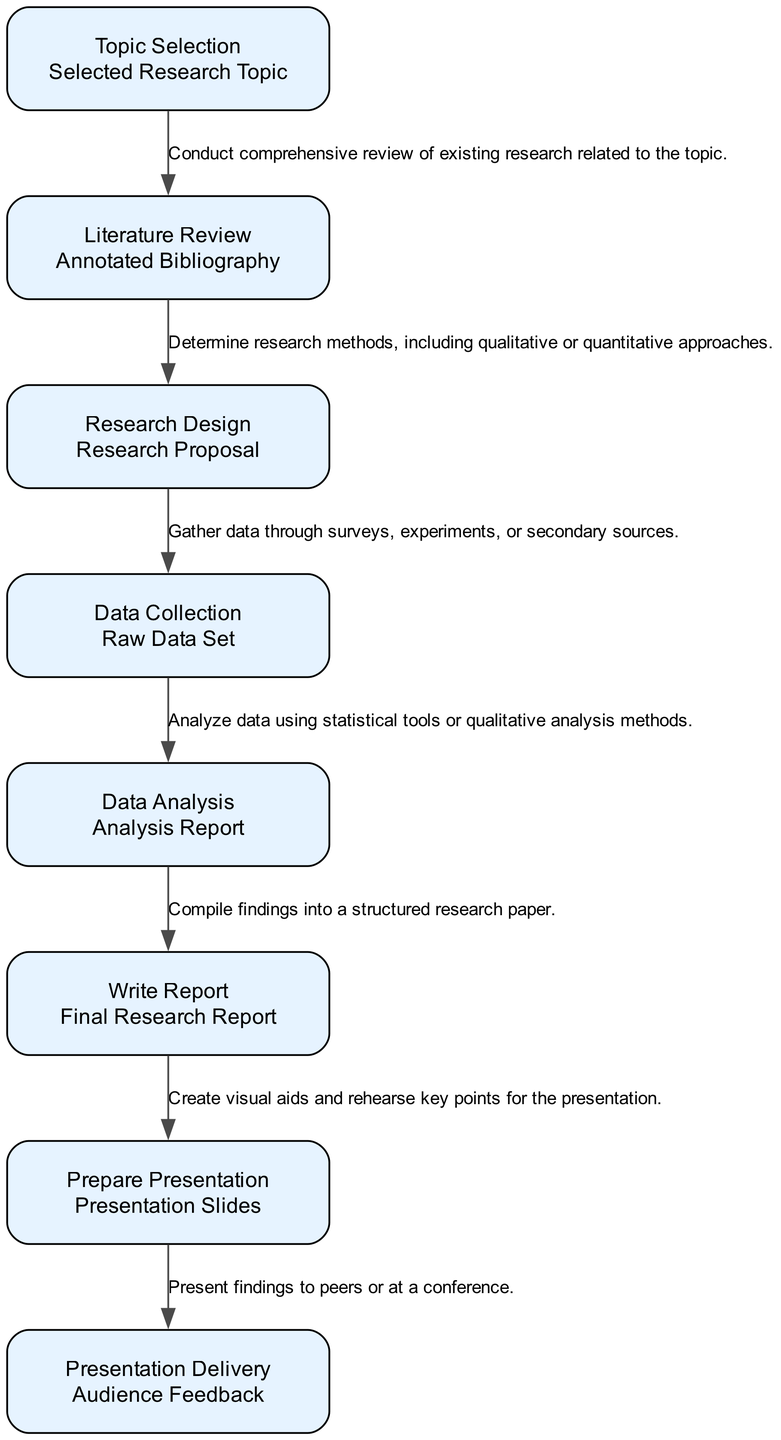What is the first step in the research project workflow? The workflow begins with "Topic Selection" as the first step. This is clearly indicated as the starting point in the diagram.
Answer: Topic Selection How many steps are in the research project workflow? By counting each distinct step listed in the diagram, there are eight steps in total.
Answer: 8 What is the output of the "Data Analysis" step? The output of the "Data Analysis" step is detailed in the diagram and is labeled as "Analysis Report."
Answer: Analysis Report What follows the "Research Design" step in the workflow? The workflow indicates that "Data Collection" follows "Research Design." This is shown by the arrow connecting these two steps in the diagram.
Answer: Data Collection What is the last step of the research project workflow? Looking at the flow of the diagram, the last step is "Presentation Delivery," as it is the final node at the end of the workflow.
Answer: Presentation Delivery What is the description for the "Literature Review" step? The description associated with the "Literature Review" step is recorded in the diagram as conducting a "comprehensive review of existing research related to the topic."
Answer: Comprehensive review of existing research related to the topic Explain the relationship between "Data Collection" and "Data Analysis." In the diagram, "Data Collection" leads to "Data Analysis," indicating a sequential relationship where collected data is analyzed in the next step. Thus, without data collection, data analysis cannot occur.
Answer: Sequential relationship What is the final output generated at the end of the workflow? The workflow culminates in the output labeled as "Audience Feedback," which is produced after the "Presentation Delivery."
Answer: Audience Feedback 